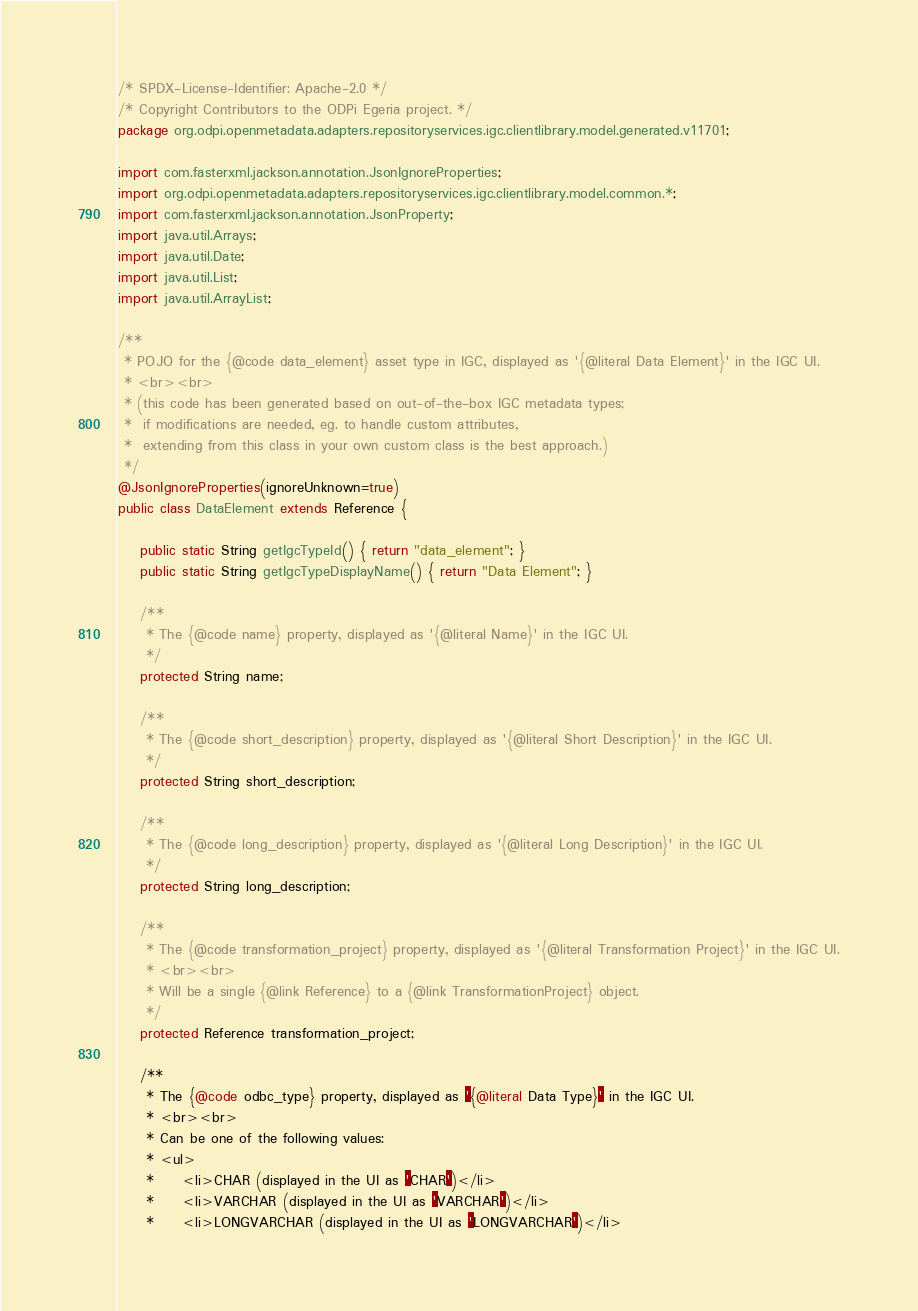<code> <loc_0><loc_0><loc_500><loc_500><_Java_>/* SPDX-License-Identifier: Apache-2.0 */
/* Copyright Contributors to the ODPi Egeria project. */
package org.odpi.openmetadata.adapters.repositoryservices.igc.clientlibrary.model.generated.v11701;

import com.fasterxml.jackson.annotation.JsonIgnoreProperties;
import org.odpi.openmetadata.adapters.repositoryservices.igc.clientlibrary.model.common.*;
import com.fasterxml.jackson.annotation.JsonProperty;
import java.util.Arrays;
import java.util.Date;
import java.util.List;
import java.util.ArrayList;

/**
 * POJO for the {@code data_element} asset type in IGC, displayed as '{@literal Data Element}' in the IGC UI.
 * <br><br>
 * (this code has been generated based on out-of-the-box IGC metadata types;
 *  if modifications are needed, eg. to handle custom attributes,
 *  extending from this class in your own custom class is the best approach.)
 */
@JsonIgnoreProperties(ignoreUnknown=true)
public class DataElement extends Reference {

    public static String getIgcTypeId() { return "data_element"; }
    public static String getIgcTypeDisplayName() { return "Data Element"; }

    /**
     * The {@code name} property, displayed as '{@literal Name}' in the IGC UI.
     */
    protected String name;

    /**
     * The {@code short_description} property, displayed as '{@literal Short Description}' in the IGC UI.
     */
    protected String short_description;

    /**
     * The {@code long_description} property, displayed as '{@literal Long Description}' in the IGC UI.
     */
    protected String long_description;

    /**
     * The {@code transformation_project} property, displayed as '{@literal Transformation Project}' in the IGC UI.
     * <br><br>
     * Will be a single {@link Reference} to a {@link TransformationProject} object.
     */
    protected Reference transformation_project;

    /**
     * The {@code odbc_type} property, displayed as '{@literal Data Type}' in the IGC UI.
     * <br><br>
     * Can be one of the following values:
     * <ul>
     *     <li>CHAR (displayed in the UI as 'CHAR')</li>
     *     <li>VARCHAR (displayed in the UI as 'VARCHAR')</li>
     *     <li>LONGVARCHAR (displayed in the UI as 'LONGVARCHAR')</li></code> 